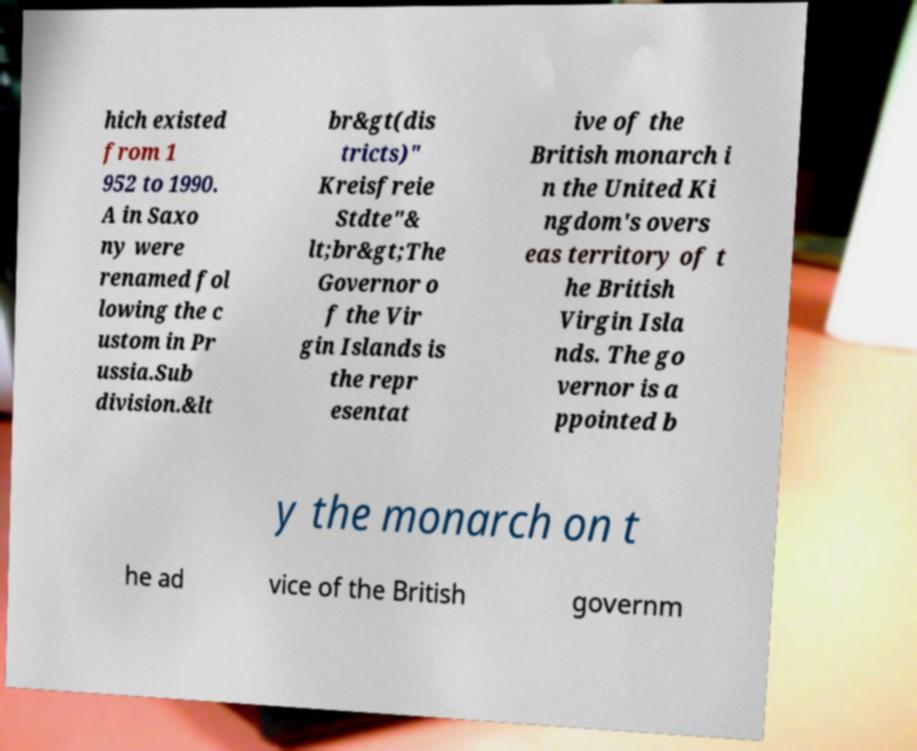Please read and relay the text visible in this image. What does it say? hich existed from 1 952 to 1990. A in Saxo ny were renamed fol lowing the c ustom in Pr ussia.Sub division.&lt br&gt(dis tricts)" Kreisfreie Stdte"& lt;br&gt;The Governor o f the Vir gin Islands is the repr esentat ive of the British monarch i n the United Ki ngdom's overs eas territory of t he British Virgin Isla nds. The go vernor is a ppointed b y the monarch on t he ad vice of the British governm 